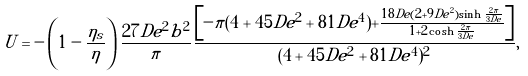Convert formula to latex. <formula><loc_0><loc_0><loc_500><loc_500>U = - \left ( 1 - \frac { \eta _ { s } } { \eta } \right ) \frac { 2 7 D e ^ { 2 } b ^ { 2 } } { \pi } \frac { \left [ - \pi ( 4 + 4 5 D e ^ { 2 } + 8 1 D e ^ { 4 } ) + \frac { 1 8 D e ( 2 + 9 D e ^ { 2 } ) \sinh \frac { 2 \pi } { 3 D e } } { 1 + 2 \cosh { \frac { 2 \pi } { 3 D e } } } \right ] } { ( 4 + 4 5 D e ^ { 2 } + 8 1 D e ^ { 4 } ) ^ { 2 } } ,</formula> 